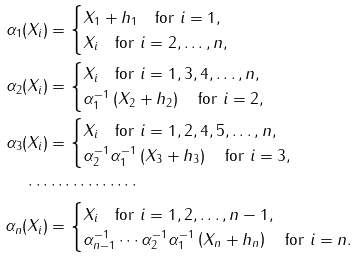<formula> <loc_0><loc_0><loc_500><loc_500>\alpha _ { 1 } ( X _ { i } ) & = \begin{cases} X _ { 1 } + h _ { 1 } \quad \text {for} \ i = 1 , \\ X _ { i } \quad \text {for} \ i = 2 , \dots , n , \end{cases} \\ \alpha _ { 2 } ( X _ { i } ) & = \begin{cases} X _ { i } \quad \text {for} \ i = 1 , 3 , 4 , \dots , n , \\ \alpha _ { 1 } ^ { - 1 } \left ( X _ { 2 } + h _ { 2 } \right ) \quad \text {for} \ i = 2 , \end{cases} \\ \alpha _ { 3 } ( X _ { i } ) & = \begin{cases} X _ { i } \quad \text {for} \ i = 1 , 2 , 4 , 5 , \dots , n , \\ \alpha _ { 2 } ^ { - 1 } \alpha _ { 1 } ^ { - 1 } \left ( X _ { 3 } + h _ { 3 } \right ) \quad \text {for} \ i = 3 , \end{cases} \\ \cdots & \cdots \cdots \cdots \cdots \\ \alpha _ { n } ( X _ { i } ) & = \begin{cases} X _ { i } \quad \text {for} \ i = 1 , 2 , \dots , n - 1 , \\ \alpha _ { n - 1 } ^ { - 1 } \cdots \alpha _ { 2 } ^ { - 1 } \alpha _ { 1 } ^ { - 1 } \left ( X _ { n } + h _ { n } \right ) \quad \text {for} \ i = n . \end{cases}</formula> 